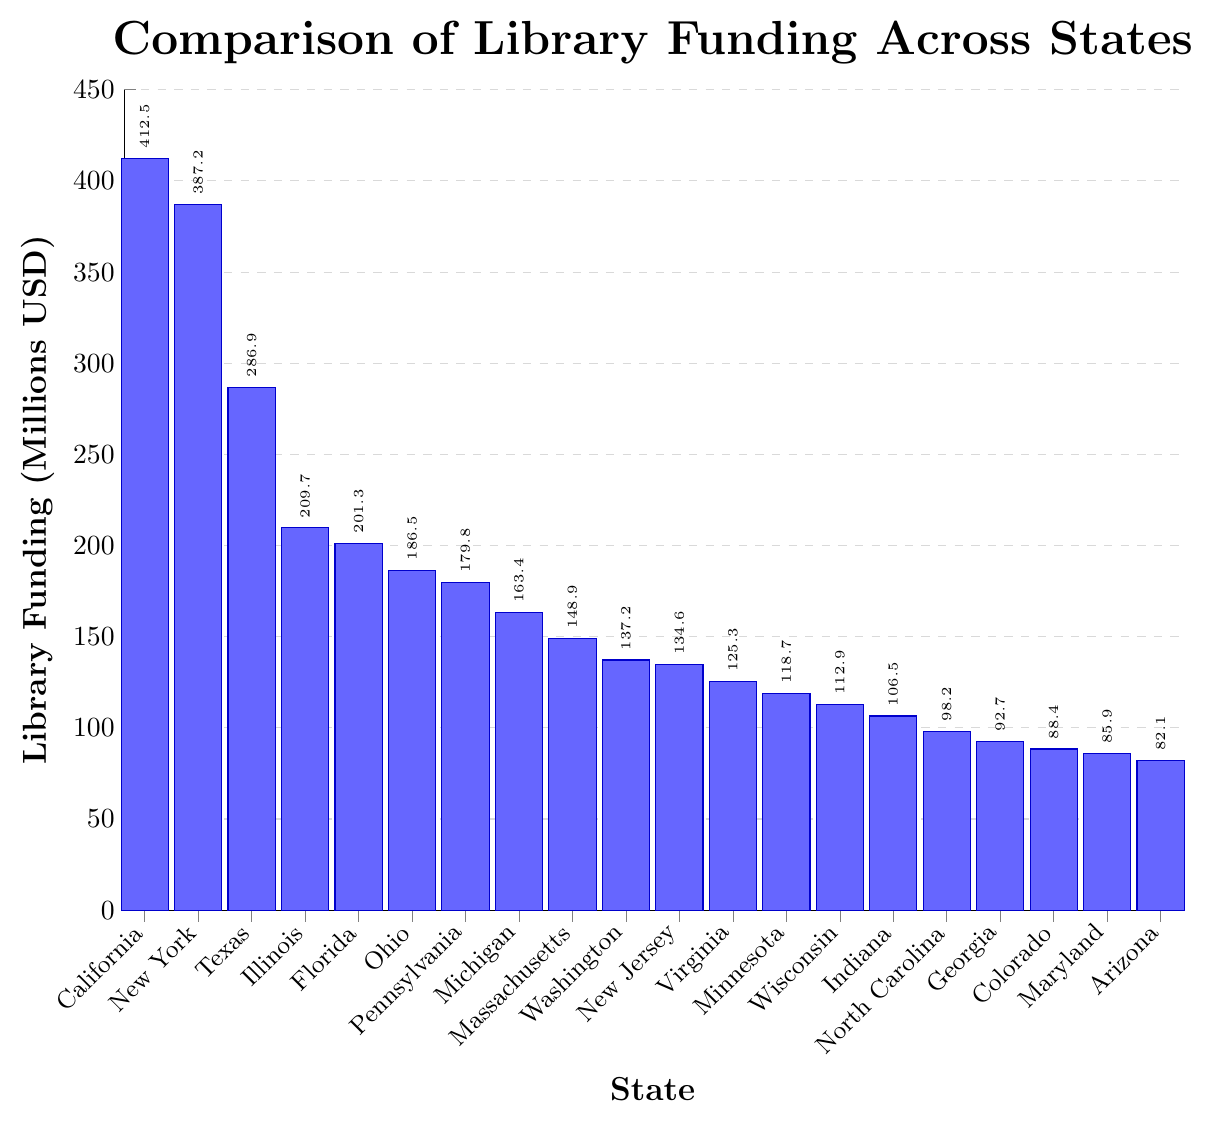Which state has the highest library funding? The bar corresponding to California is the tallest among all bars, indicating it has the highest library funding.
Answer: California What is the library funding difference between California and New York? The funding for California is 412.5 million USD and for New York is 387.2 million USD. The difference is 412.5 - 387.2 = 25.3 million USD.
Answer: 25.3 million USD Among the states listed, which has the lowest library funding? The bar for Arizona is the shortest, indicating it has the lowest library funding at 82.1 million USD.
Answer: Arizona How much more library funding does Texas receive compared to Ohio? Texas receives 286.9 million USD while Ohio receives 186.5 million USD. The difference is 286.9 - 186.5 = 100.4 million USD.
Answer: 100.4 million USD Which states have library funding greater than 200 million USD? From the figure, the states with funding above 200 million USD are California (412.5), New York (387.2), Texas (286.9), Illinois (209.7), and Florida (201.3).
Answer: California, New York, Texas, Illinois, Florida What is the combined library funding for New Jersey, Virginia, and Minnesota? Adding the funding for these states: New Jersey (134.6) + Virginia (125.3) + Minnesota (118.7) = 378.6 million USD.
Answer: 378.6 million USD Which state has funding closest to the median value of the dataset provided? To find the median, we list the funding values in order and locate the middle. The median funding value is between Ohio (186.5) and Pennsylvania (179.8). The closest state to these values is Ohio.
Answer: Ohio How much more library funding does the top state receive compared to the bottom state? The top state, California, has 412.5 million USD, and the bottom state, Arizona, has 82.1 million USD. The difference is 412.5 - 82.1 = 330.4 million USD.
Answer: 330.4 million USD Which states have a funding amount between 100 and 150 million USD? From the chart, the states falling in this range are New Jersey (134.6), Virginia (125.3), Minnesota (118.7), Wisconsin (112.9), and Indiana (106.5).
Answer: New Jersey, Virginia, Minnesota, Wisconsin, Indiana What is the total library funding for all the states represented in the chart? Summing all the values: 412.5 + 387.2 + 286.9 + 209.7 + 201.3 + 186.5 + 179.8 + 163.4 + 148.9 + 137.2 + 134.6 + 125.3 + 118.7 + 112.9 + 106.5 + 98.2 + 92.7 + 88.4 + 85.9 + 82.1 = 3358.6 million USD.
Answer: 3358.6 million USD 